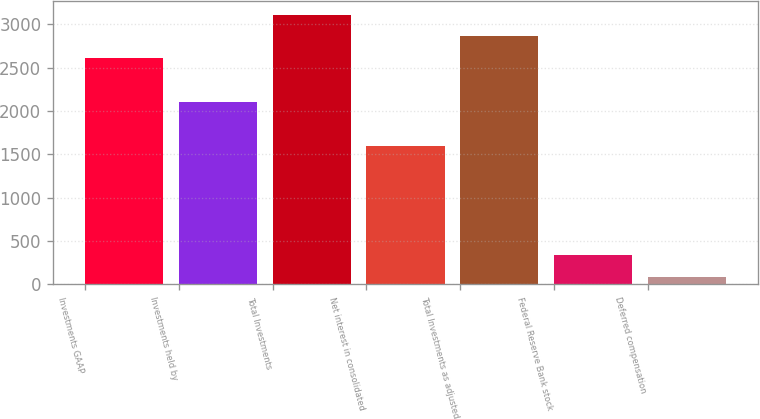Convert chart. <chart><loc_0><loc_0><loc_500><loc_500><bar_chart><fcel>Investments GAAP<fcel>Investments held by<fcel>Total Investments<fcel>Net interest in consolidated<fcel>Total Investments as adjusted<fcel>Federal Reserve Bank stock<fcel>Deferred compensation<nl><fcel>2608<fcel>2102.2<fcel>3113.8<fcel>1596.4<fcel>2860.9<fcel>331.9<fcel>79<nl></chart> 